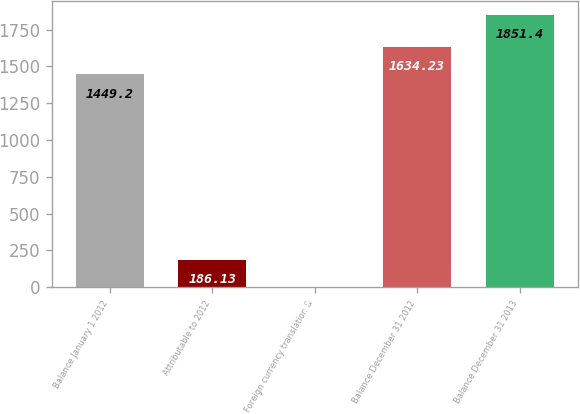<chart> <loc_0><loc_0><loc_500><loc_500><bar_chart><fcel>Balance January 1 2012<fcel>Attributable to 2012<fcel>Foreign currency translation &<fcel>Balance December 31 2012<fcel>Balance December 31 2013<nl><fcel>1449.2<fcel>186.13<fcel>1.1<fcel>1634.23<fcel>1851.4<nl></chart> 